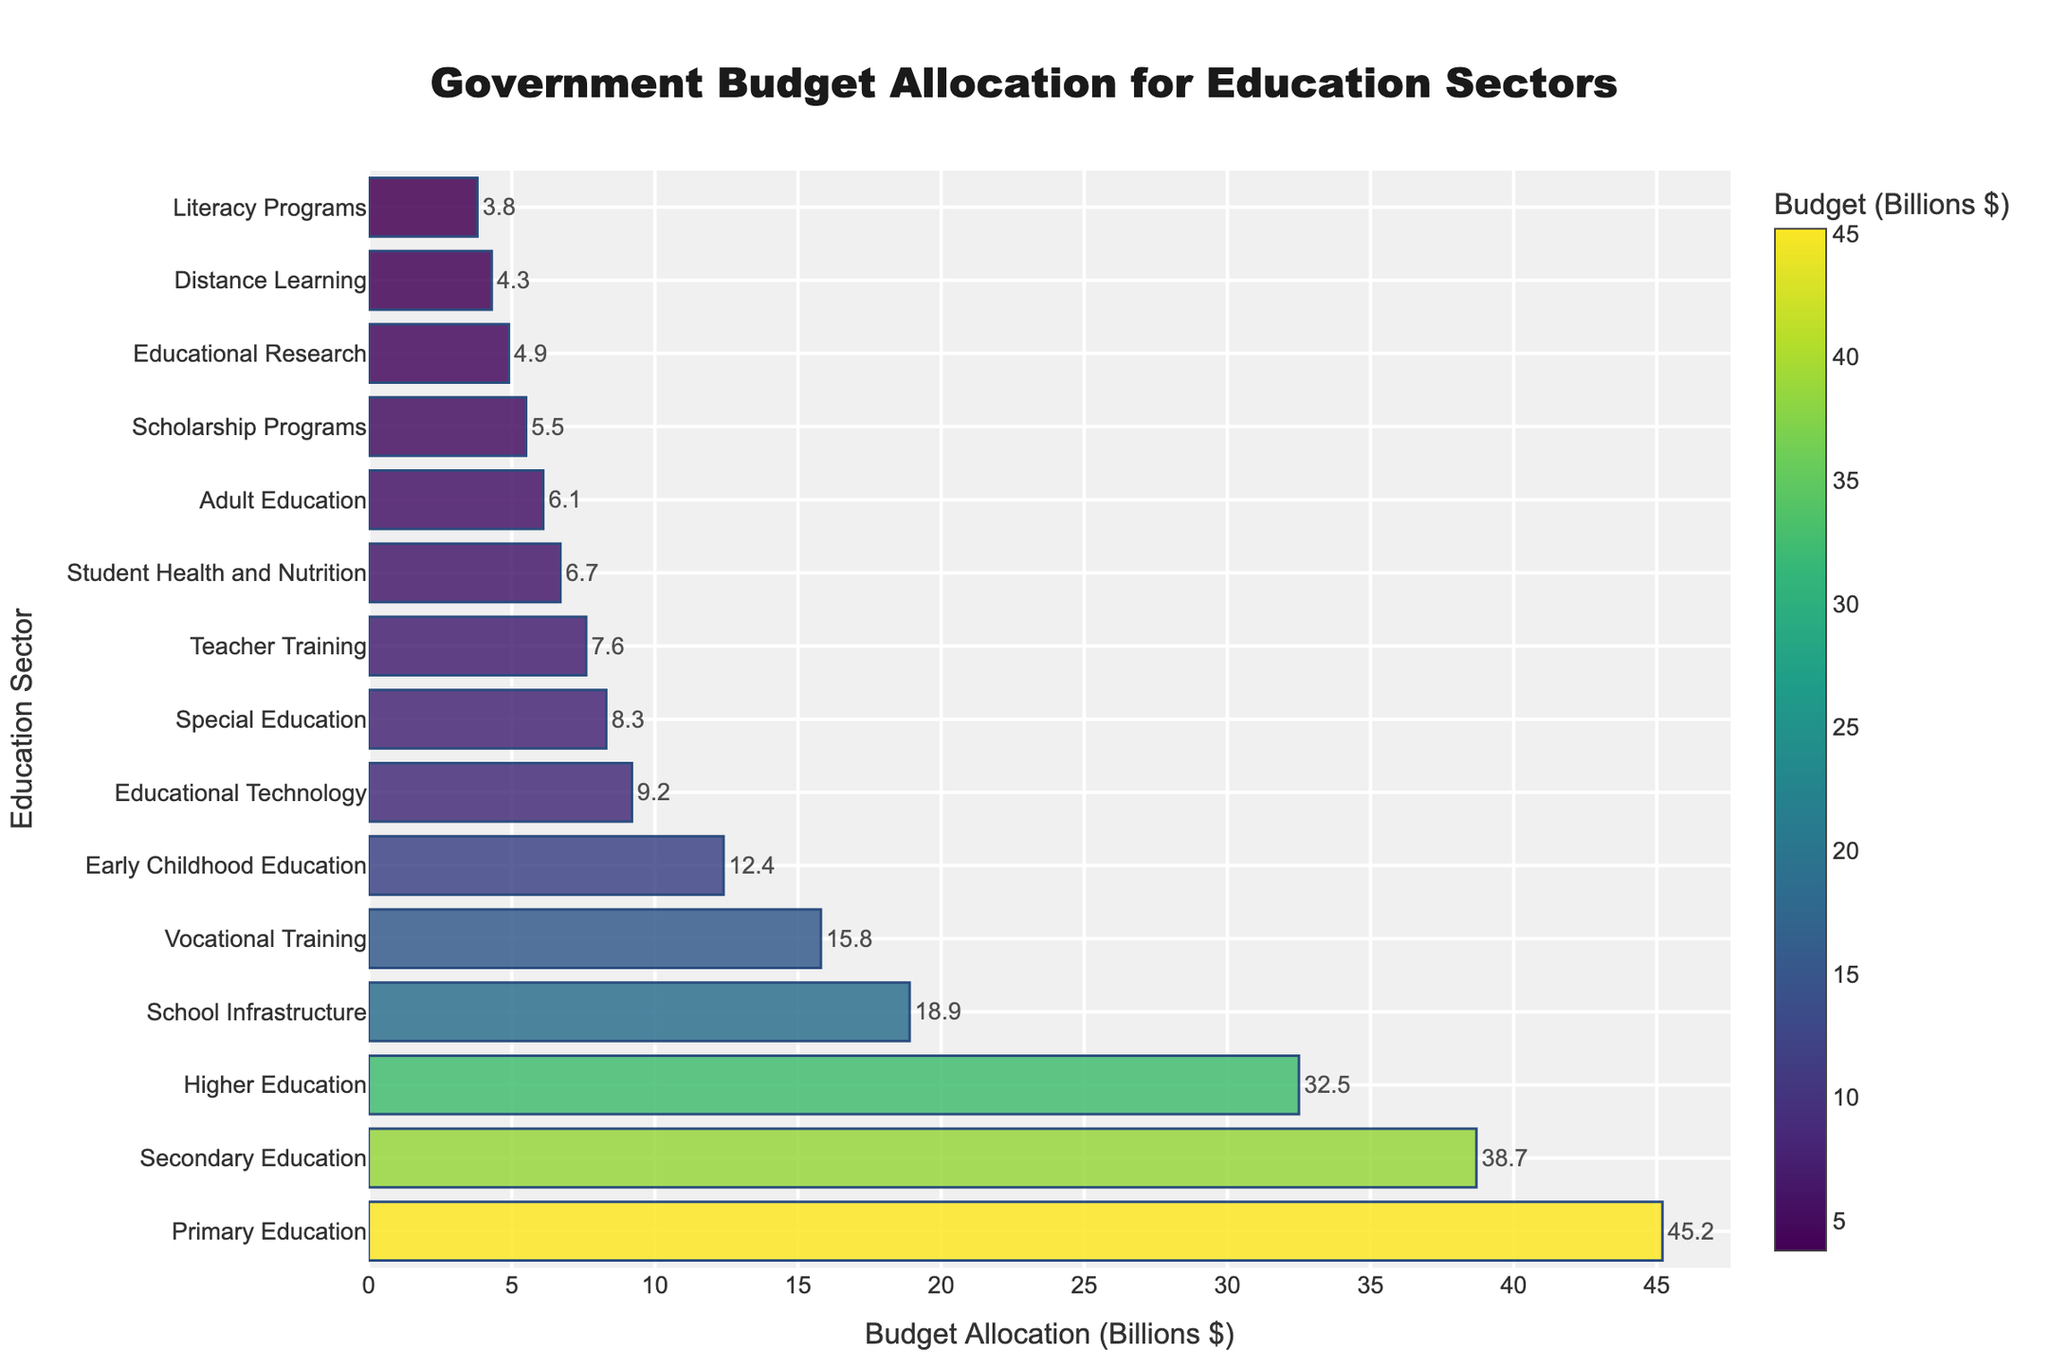Which education sector has the largest budget allocation? The bar representing Primary Education is the longest and is positioned at the top of the chart, indicating it has the highest budget allocation.
Answer: Primary Education How much more is allocated to Primary Education than to Higher Education? The budget allocation for Primary Education is $45.2 billion, and for Higher Education, it is $32.5 billion. The difference is $45.2 billion - $32.5 billion = $12.7 billion.
Answer: $12.7 billion What is the total budget allocation for Secondary Education and School Infrastructure? The budget for Secondary Education is $38.7 billion and for School Infrastructure is $18.9 billion. Adding them gives $38.7 billion + $18.9 billion = $57.6 billion.
Answer: $57.6 billion Which three education sectors have the smallest budget allocations? The bars for Literacy Programs, Distance Learning, and Educational Research are the shortest, indicating they have the smallest budgets of $3.8 billion, $4.3 billion, and $4.9 billion, respectively.
Answer: Literacy Programs, Distance Learning, Educational Research What is the average budget allocation for the top five sectors? The top five sectors and their budgets are: Primary Education ($45.2 billion), Secondary Education ($38.7 billion), Higher Education ($32.5 billion), School Infrastructure ($18.9 billion), and Vocational Training ($15.8 billion). The average is ($45.2 billion + $38.7 billion + $32.5 billion + $18.9 billion + $15.8 billion) / 5 = $151.1 billion / 5 = $30.22 billion.
Answer: $30.22 billion How does the budget allocation for Teacher Training compare to that for Adult Education? The budget for Teacher Training is $7.6 billion and for Adult Education is $6.1 billion. Teacher Training has a higher budget allocation than Adult Education by $7.6 billion - $6.1 billion = $1.5 billion.
Answer: Teacher Training has a higher budget by $1.5 billion What is the combined budget allocation for Special Education, Adult Education, and Early Childhood Education? The budget allocations are $8.3 billion for Special Education, $6.1 billion for Adult Education, and $12.4 billion for Early Childhood Education. The combined budget is $8.3 billion + $6.1 billion + $12.4 billion = $26.8 billion.
Answer: $26.8 billion Which sectors have budget allocations that are less than $10 billion? The sectors with budget allocations less than $10 billion are Special Education ($8.3 billion), Adult Education ($6.1 billion), Educational Research ($4.9 billion), Teacher Training ($7.6 billion), Educational Technology ($9.2 billion), Literacy Programs ($3.8 billion), Scholarship Programs ($5.5 billion), and Distance Learning ($4.3 billion).
Answer: Special Education, Adult Education, Educational Research, Teacher Training, Educational Technology, Literacy Programs, Scholarship Programs, Distance Learning What is the total budget allocated to all education sectors in the figure? Summing the budgets of all sectors: $45.2 billion (Primary) + $38.7 billion (Secondary) + $32.5 billion (Higher) + $15.8 billion (Vocational) + $8.3 billion (Special) + $6.1 billion (Adult) + $12.4 billion (Early Childhood) + $4.9 billion (Research) + $7.6 billion (Teacher Training) + $9.2 billion (Technology) + $3.8 billion (Literacy) + $5.5 billion (Scholarship) + $18.9 billion (Infrastructure) + $6.7 billion (Health and Nutrition) + $4.3 billion (Distance Learning) = $220 billion.
Answer: $220 billion 